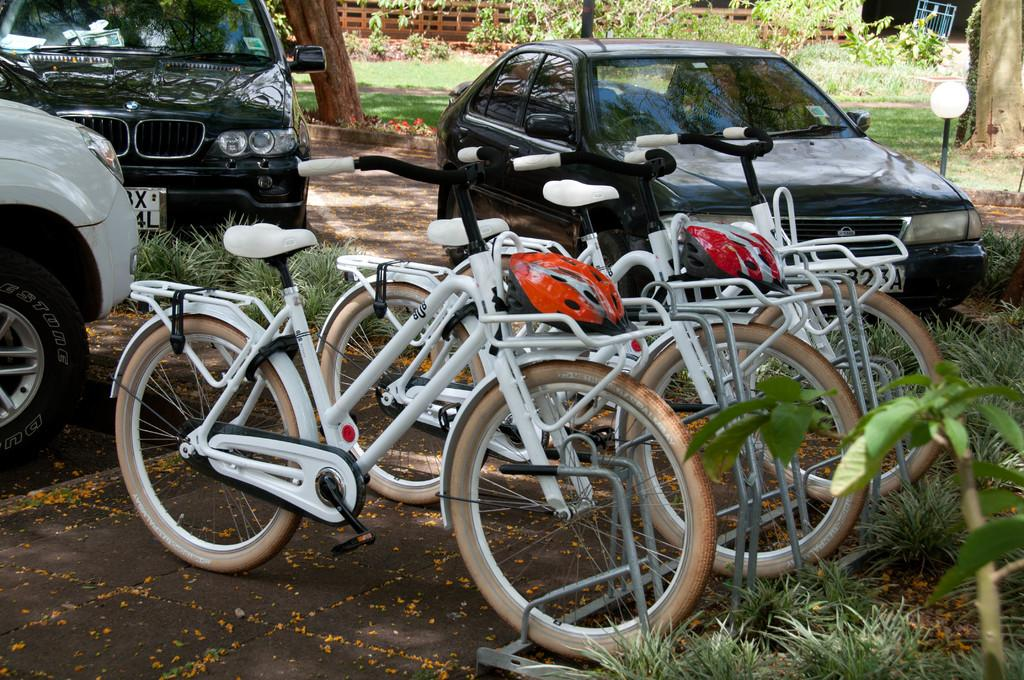What types of transportation are present in the image? There are vehicles and bicycles in the image. How are the bicycles positioned in relation to the vehicles? The bicycles are parked between the vehicles. What type of natural environment is visible in the image? There is grass visible in the image, and trees and plants are present in the background. What type of barrier is visible in the background of the image? There is a wooden fence in the background of the image. What type of art can be seen hanging on the wooden fence in the image? There is no art visible on the wooden fence in the image. What type of basin is used for washing the bicycles in the image? There is no basin present in the image, and the bicycles are parked, not being washed. 